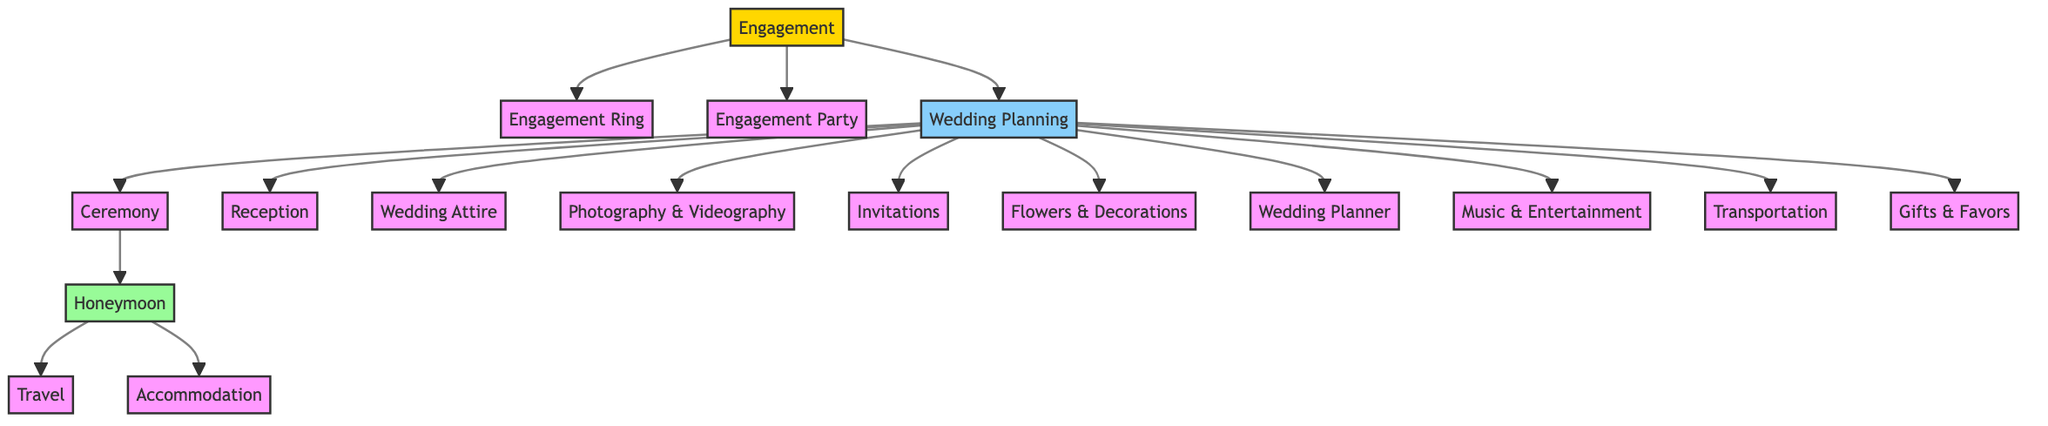What is the first step in the wedding planning process? The diagram shows that the first step is "Engagement," which is the starting node connected to the engagement ring, engagement party, and wedding planning.
Answer: Engagement How many nodes represent the wedding ceremony and reception combined? The nodes "Ceremony" and "Reception" are both connected to the "Wedding Planning" node. Thus, there are 2 nodes that represent them.
Answer: 2 Which node is directly connected to both the ceremony and the honeymoon? The "Ceremony" node is connected to the "Honeymoon" node through an edge, hence it is the node directly involved with both.
Answer: Ceremony What is the total number of edges in the diagram? By counting the directed connections (edges) between the nodes, there are 15 edges that illustrate the relationships in the budget allocation process.
Answer: 15 What do the two nodes beneath the honeymoon represent? The nodes "Travel" and "Accommodation" are the two nodes directly linked under the "Honeymoon" node, which indicates the components of the honeymoon.
Answer: Travel and Accommodation Which node connects all aspects of the wedding planning? The node "Wedding Planning" acts as a central hub, connecting to all subsequent components required for the wedding, including ceremony, reception, and various services.
Answer: Wedding Planning How many types of services are included in the wedding planning node? The "Wedding Planning" node connects to 8 different service-related nodes: Ceremony, Reception, Wedding Attire, Photography & Videography, Invitations, Flowers & Decorations, Wedding Planner, Music & Entertainment, and Transportation.
Answer: 8 What node follows the engagement in the planning process? After "Engagement," the next node in the process is "Wedding Planning," which indicates the subsequent step in organizing the wedding.
Answer: Wedding Planning Which two components are linked directly after the ceremony is conducted? The "Honeymoon" node is connected to "Travel" and "Accommodation," indicating what follows after the wedding ceremony.
Answer: Travel and Accommodation 